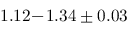Convert formula to latex. <formula><loc_0><loc_0><loc_500><loc_500>1 . 1 2 \, - \, 1 . 3 4 \pm 0 . 0 3</formula> 